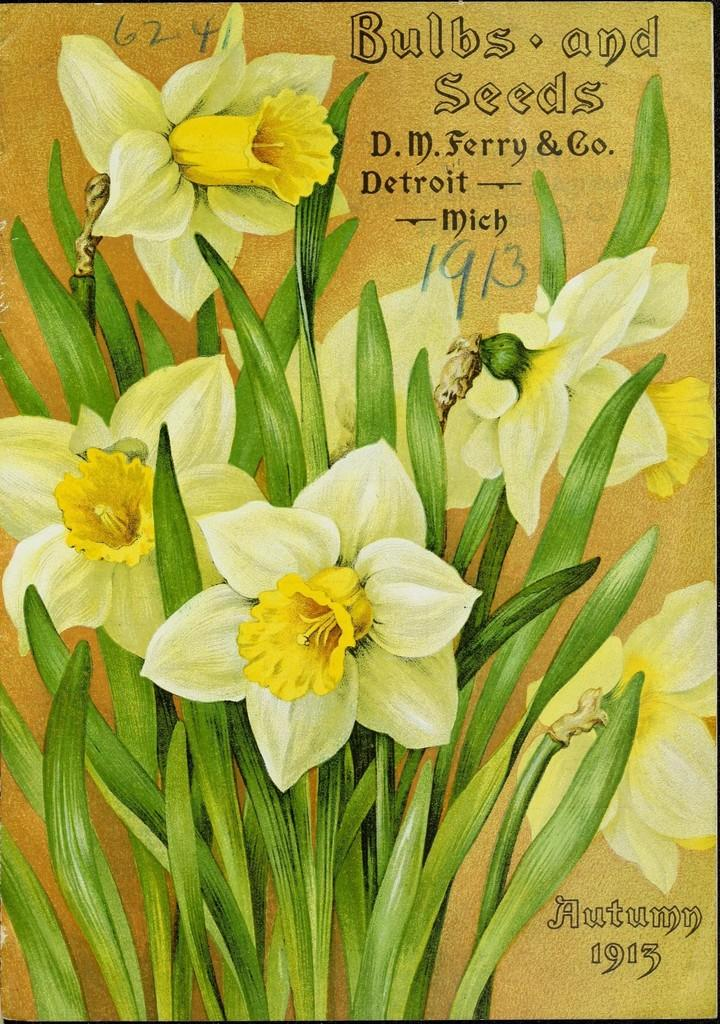What is featured in the picture? There is a poster in the picture. What type of image is on the poster? The poster contains flowers with stems. Is there any text on the poster? Yes, there is text on the poster. How many parcels are shown being delivered in the image? There are no parcels or delivery depicted in the image; it features a poster with flowers and text. What is the fifth flower on the poster? There is no mention of a specific number of flowers on the poster, so it is impossible to determine the fifth flower. 